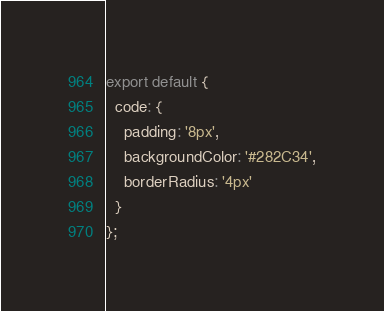<code> <loc_0><loc_0><loc_500><loc_500><_JavaScript_>export default {
  code: {
    padding: '8px',
    backgroundColor: '#282C34',
    borderRadius: '4px'
  }
};
</code> 